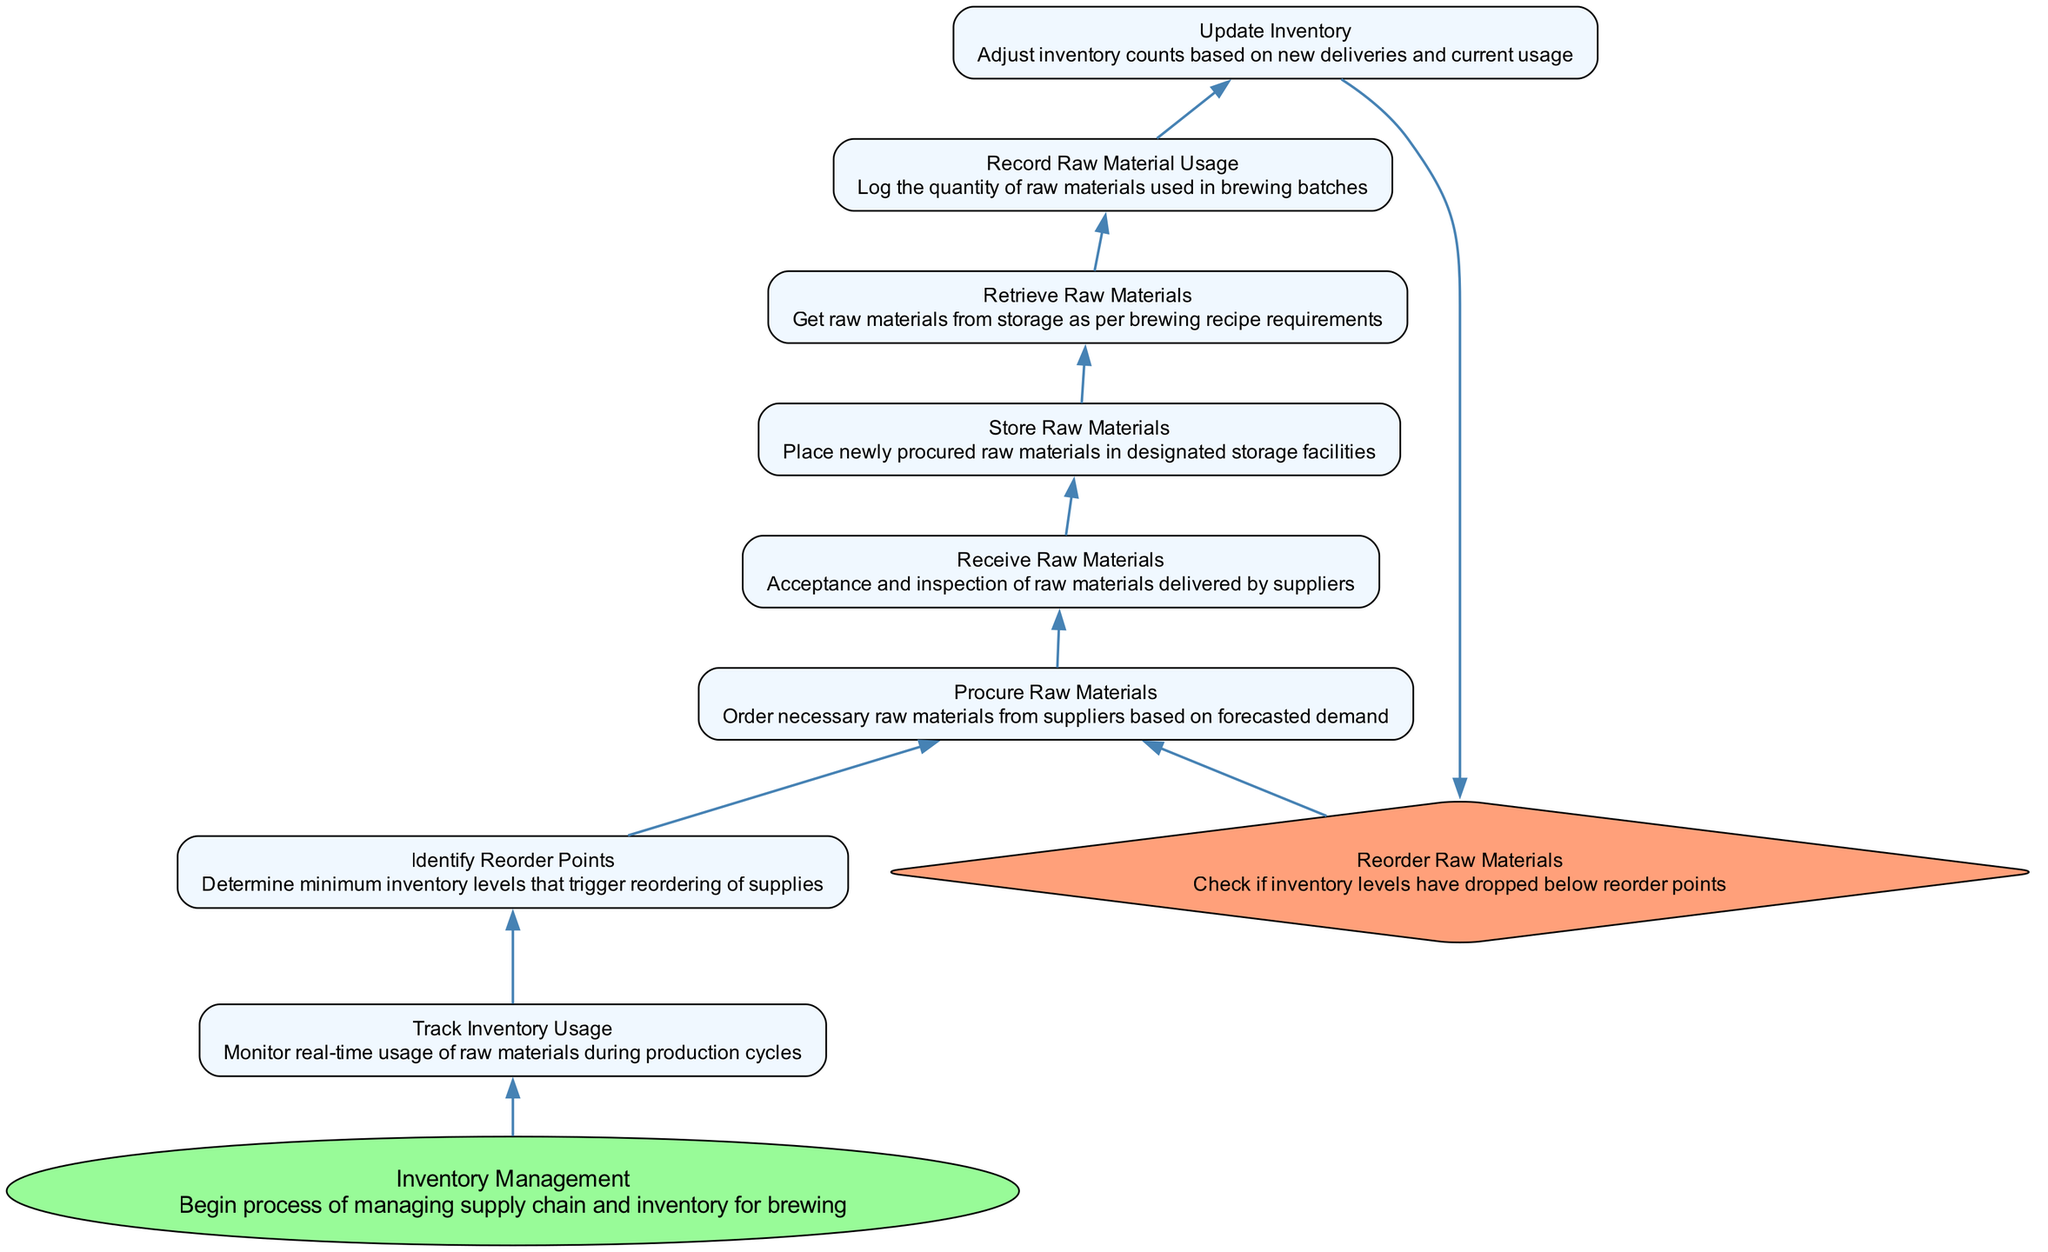What is the first step in the flowchart? The flowchart begins with the "Inventory Management" node, which indicates the initiation of the processes involved in managing supply chain and inventory for brewing.
Answer: Inventory Management How many processes are shown in the diagram? The diagram includes eight processes: Update Inventory, Record Raw Material Usage, Retrieve Raw Materials, Store Raw Materials, Receive Raw Materials, Procure Raw Materials, Identify Reorder Points, and Track Inventory Usage.
Answer: Eight Which node directly follows "Track Inventory Usage"? In the flowchart, "Identify Reorder Points" is the node that comes directly after "Track Inventory Usage," establishing the next step after monitoring raw material usage.
Answer: Identify Reorder Points What is the purpose of the "Reorder Raw Materials" node? The "Reorder Raw Materials" node is a decision point that checks whether the inventory levels have dropped below predetermined reorder points, determining if the ordering process needs to be triggered.
Answer: Check inventory levels How does the flow move from "Update Inventory"? After "Update Inventory," the flow continues to "Reorder Raw Materials," indicating that after adjusting inventory counts, it's necessary to decide if reordering is needed based on current levels.
Answer: To Reorder Raw Materials What processes fall between receiving raw materials and tracking their usage? The processes between receiving raw materials and tracking their usage are: "Store Raw Materials," followed by "Retrieve Raw Materials," leading into "Record Raw Material Usage." This sequence highlights the handling of materials from receipt to usage log.
Answer: Store Raw Materials, Retrieve Raw Materials, Record Raw Material Usage How does the diagram handle inventory management cycles? The flow demonstrates inventory management cycles by showing a loop from "Reorder Raw Materials" back to "Procure Raw Materials," indicating that reordering leads back to the procurement stage, reflecting ongoing cycles for maintaining inventory levels.
Answer: Looping process What type of node is "Receive Raw Materials"? "Receive Raw Materials" is categorized as a process node, which involves the acceptance and inspection of materials delivered by suppliers, indicating an action stage in the workflow.
Answer: Process 